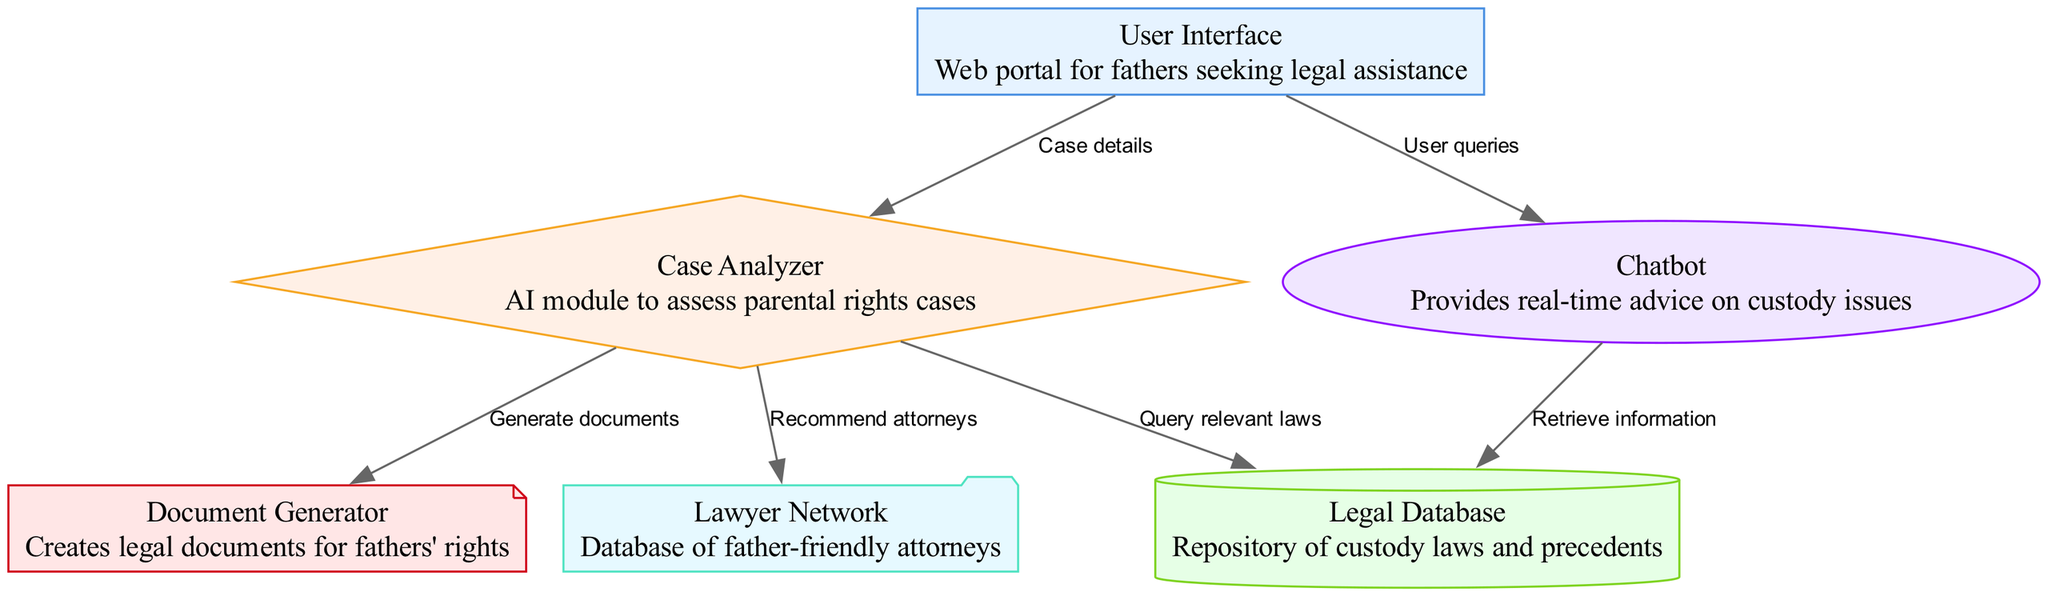What is the main function of the User Interface? The User Interface is designed as a web portal for fathers seeking legal assistance, which can be determined by the node description in the diagram.
Answer: Web portal for fathers seeking legal assistance How many nodes are present in the diagram? By counting all the unique entities that are represented as nodes, there are six nodes in total: User Interface, Case Analyzer, Legal Database, Document Generator, Chatbot, and Lawyer Network.
Answer: 6 What does the Case Analyzer connect to? The Case Analyzer has three outbound connections: it connects to the Legal Database to query relevant laws, to the Document Generator to generate documents, and to the Lawyer Network to recommend attorneys.
Answer: Legal Database, Document Generator, Lawyer Network What type of data does the Chatbot provide? The Chatbot provides real-time advice on custody issues, as identified in its node description, which informs us that its primary function is to assist users with immediate queries.
Answer: Real-time advice on custody issues How does the Document Generator receive its input? The Document Generator receives input from the Case Analyzer, which generates documents based on the analysis of parental rights cases, making it dependent on the output from the Case Analyzer node.
Answer: From the Case Analyzer What is the relationship between the Chatbot and the Legal Database? The relationship is that the Chatbot retrieves information from the Legal Database. This is indicated by the directed edge that connects Chatbot to Legal Database, showing the flow of information.
Answer: Retrieve information Which node directly provides case details to the Case Analyzer? The User Interface directly provides case details to the Case Analyzer, as shown by the directed edge labeled "Case details" linking these two nodes.
Answer: User Interface Which module recommends attorneys for fathers? The Case Analyzer is the module that recommends attorneys for fathers as indicated by its connection to the Lawyer Network and its specified role in the diagram.
Answer: Case Analyzer What does the Legal Database represent? The Legal Database represents a repository of custody laws and precedents, as outlined in the node description, highlighting its importance as a source of legal information.
Answer: Repository of custody laws and precedents 